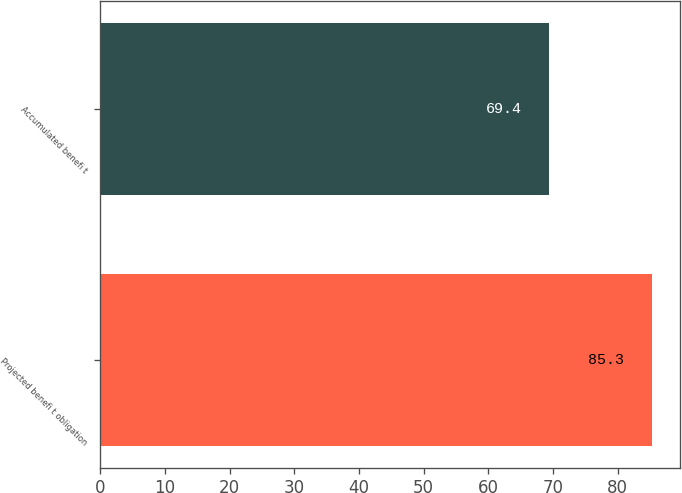Convert chart. <chart><loc_0><loc_0><loc_500><loc_500><bar_chart><fcel>Projected benefi t obligation<fcel>Accumulated benefi t<nl><fcel>85.3<fcel>69.4<nl></chart> 